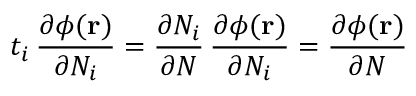Convert formula to latex. <formula><loc_0><loc_0><loc_500><loc_500>t _ { i } \, \frac { \partial \phi ( r ) } { \partial N _ { i } } = \frac { \partial N _ { i } } { \partial N } \, \frac { \partial \phi ( r ) } { \partial N _ { i } } = \frac { \partial \phi ( r ) } { \partial N }</formula> 